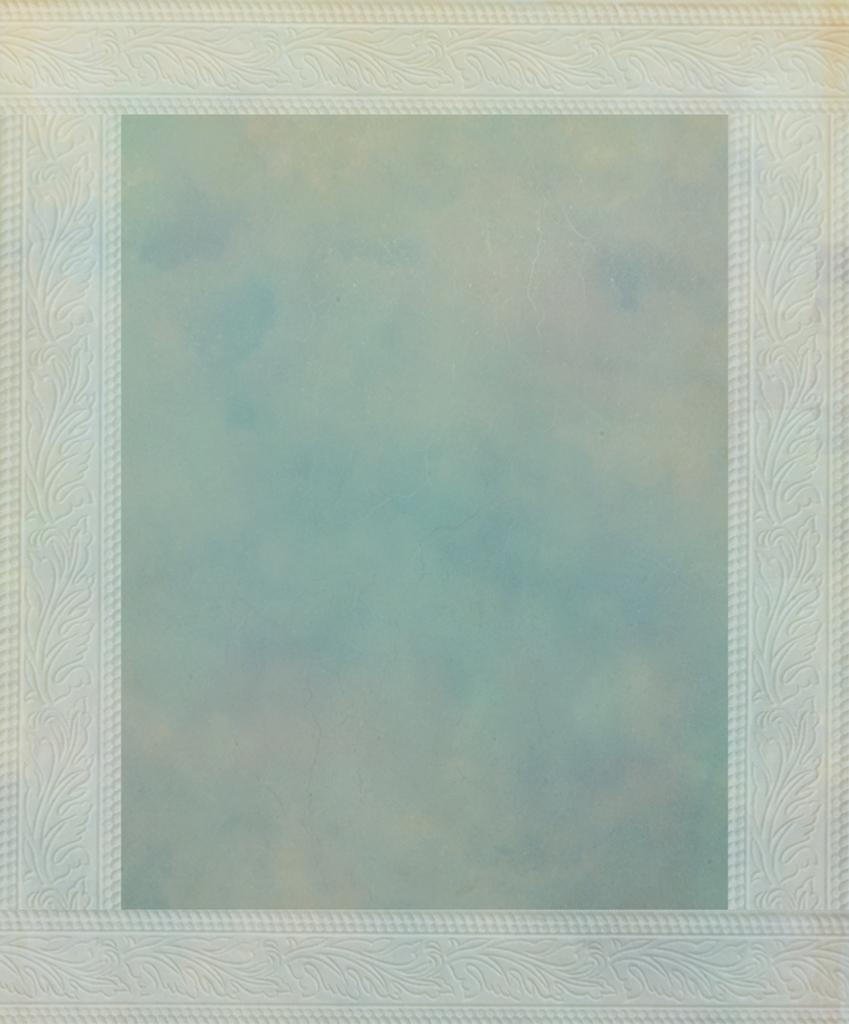What is the main object in the image? There is a frame in the image. What is depicted within the frame? The frame contains an image of the sky. How many matches are visible in the image? There are no matches present in the image. What type of trucks can be seen in the image? There are no trucks present in the image. 